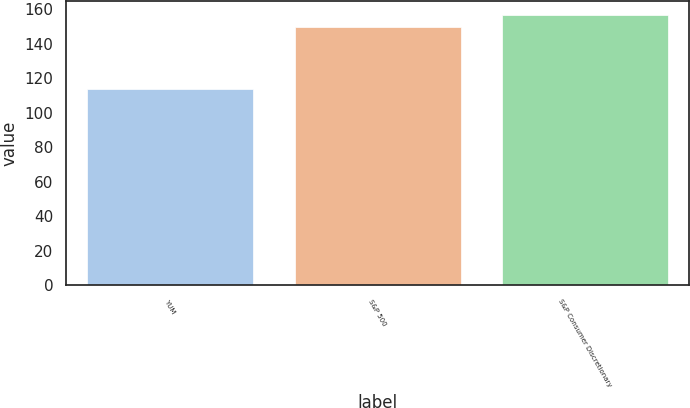Convert chart to OTSL. <chart><loc_0><loc_0><loc_500><loc_500><bar_chart><fcel>YUM<fcel>S&P 500<fcel>S&P Consumer Discretionary<nl><fcel>114<fcel>150<fcel>157<nl></chart> 